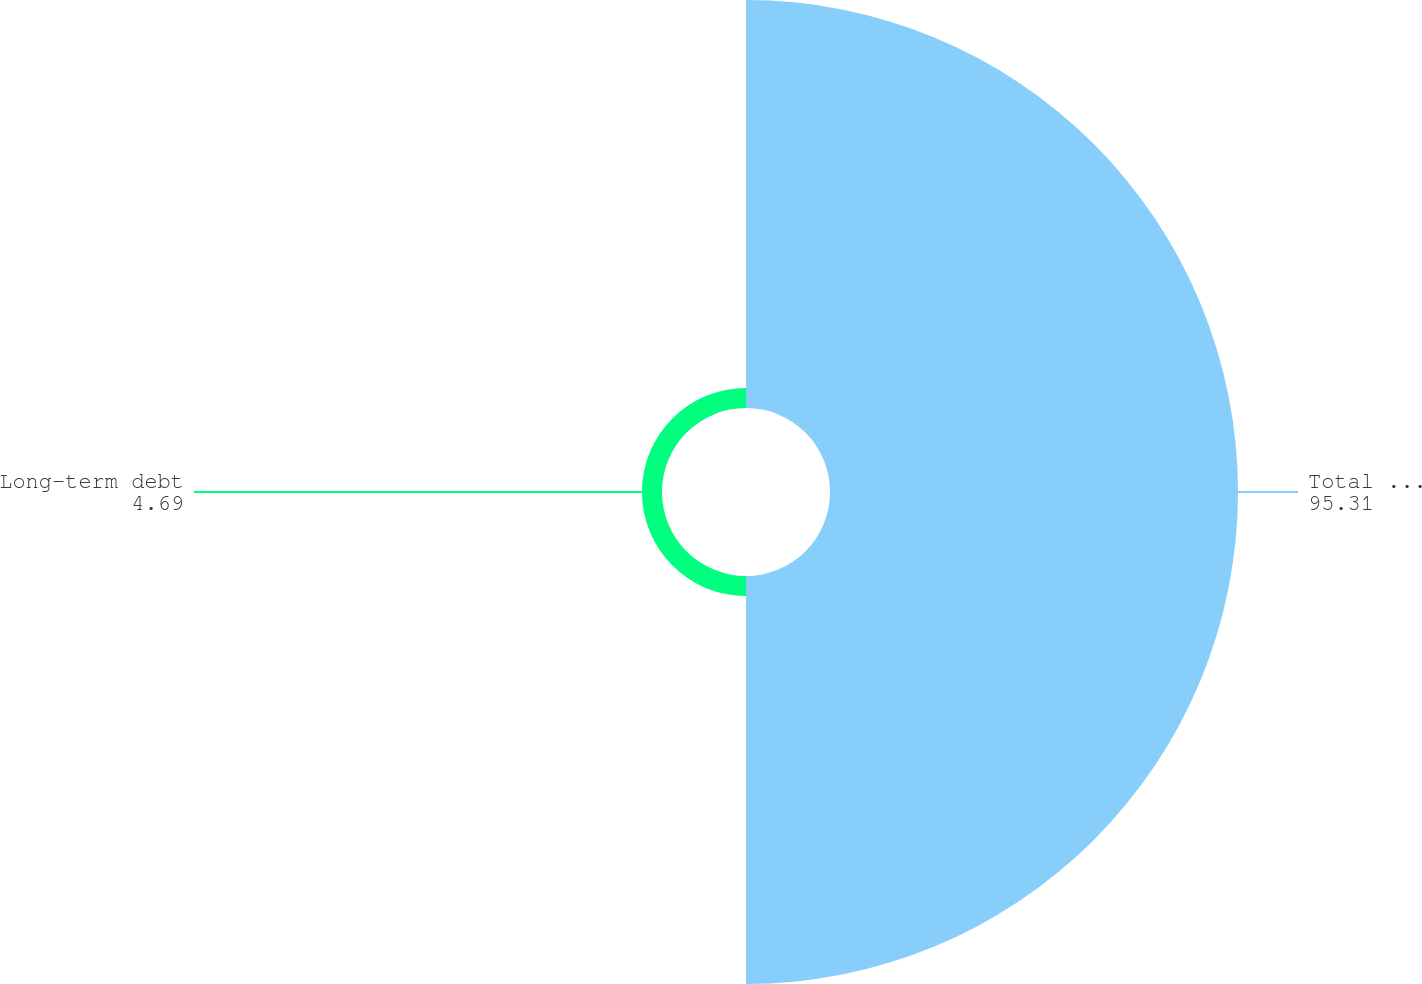Convert chart to OTSL. <chart><loc_0><loc_0><loc_500><loc_500><pie_chart><fcel>Total assets<fcel>Long-term debt<nl><fcel>95.31%<fcel>4.69%<nl></chart> 